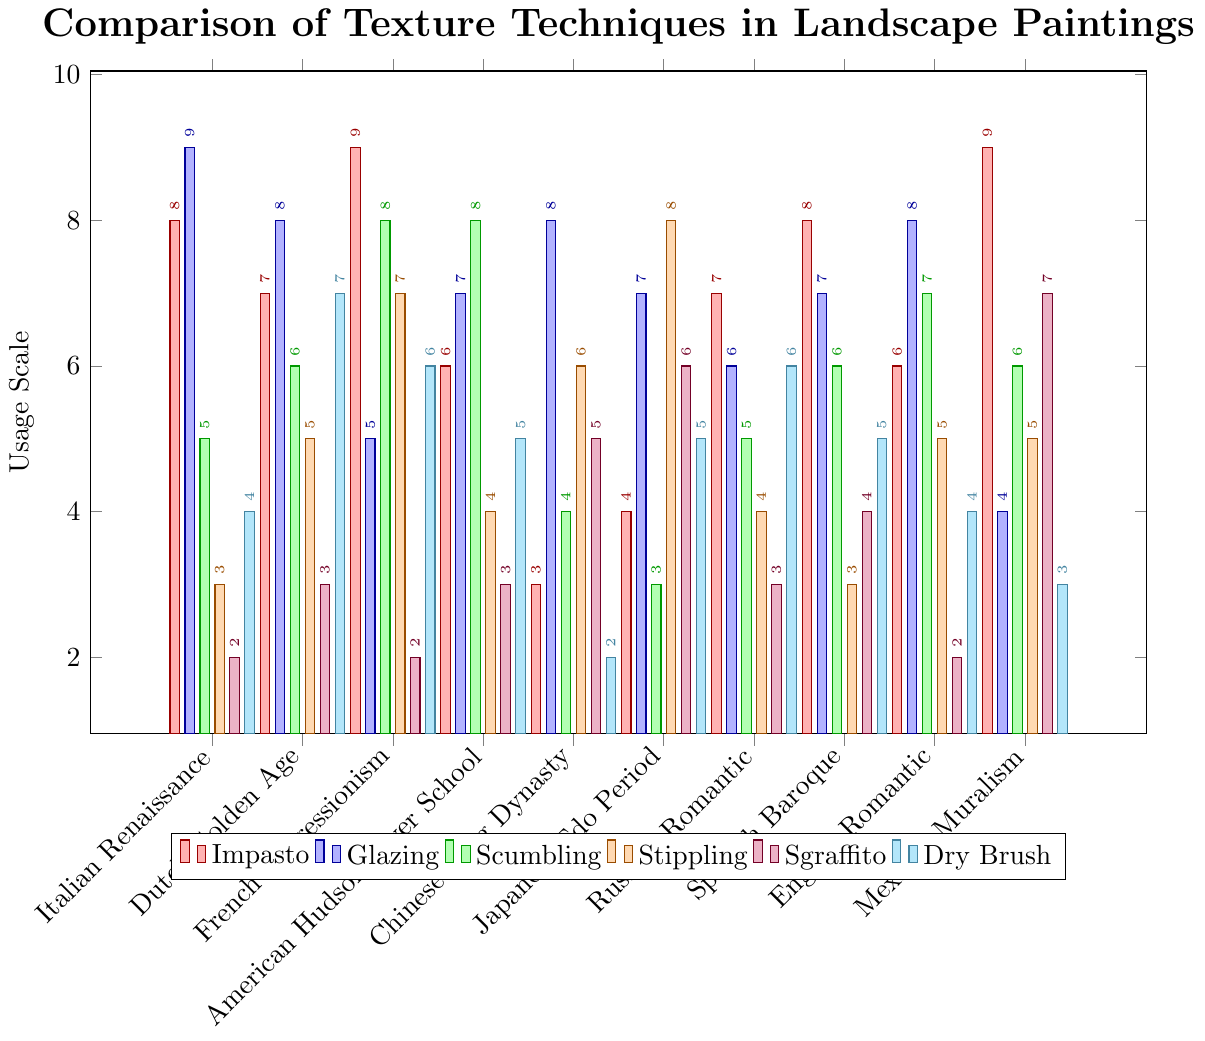Which region employs the highest usage of the Impasto technique? The bar corresponding to French Impressionism is the tallest in the Impasto color (red), which makes it the highest.
Answer: French Impressionism How many more times is the Dry Brush technique used in Dutch Golden Age compared to Chinese Song Dynasty? The usage of Dry Brush in Dutch Golden Age is 7, and in Chinese Song Dynasty, it is 2. The difference is 7 - 2 = 5.
Answer: 5 What’s the average usage of Glazing across all regions? Sum up the Glazing values (9, 8, 5, 7, 8, 7, 6, 7, 8, 4) which equals 69. There are 10 regions, so the average is 69 / 10 = 6.9.
Answer: 6.9 For which regions is the usage of Stippling greater than 5? By checking the Stippling values, regions with usage greater than 5 are French Impressionism (7), Chinese Song Dynasty (6), and Japanese Edo Period (8).
Answer: French Impressionism, Chinese Song Dynasty, Japanese Edo Period Which texture technique is least used in the Mexican Muralism region? Checking the values for Mexican Muralism, the lowest value is for Dry Brush (3).
Answer: Dry Brush How many regions have employed Sgraffito exactly 3 times? Sgraffito values equal to 3 are in Italian Renaissance, Dutch Golden Age, American Hudson River School, and Russian Romantic, making 4 regions in total.
Answer: 4 If you sum the usage of Scumbling and Stippling techniques in the American Hudson River School, what’s the total? The usage of Scumbling is 8 and Stippling is 4. Sum = 8 + 4 = 12.
Answer: 12 What’s the median value of the Impasto technique across all regions? Sorting Impasto values (8, 7, 9, 6, 3, 4, 7, 8, 6, 9), the median is the average of the 5th and 6th values (7 and 7), which is 7.
Answer: 7 Which region employs the most number of different techniques equally at the highest level? French Impressionism has the highest values for Impasto and Scumbling equally (both 9 and 8).
Answer: French Impressionism 